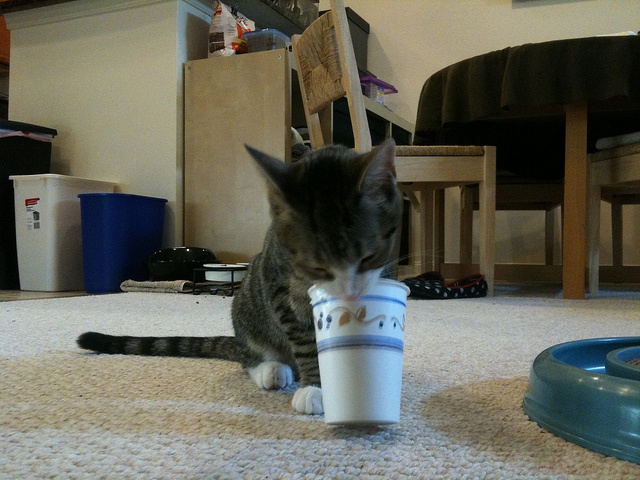Describe the objects in this image and their specific colors. I can see cat in maroon, black, gray, and darkgray tones, dining table in maroon, black, and darkgray tones, chair in maroon, olive, black, and gray tones, cup in maroon, lightblue, darkgray, and gray tones, and chair in maroon, black, darkgreen, and gray tones in this image. 